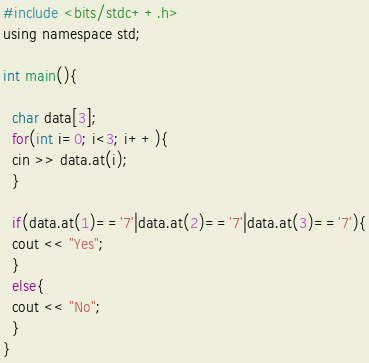Convert code to text. <code><loc_0><loc_0><loc_500><loc_500><_C_>#include <bits/stdc++.h>
using namespace std;

int main(){

  char data[3];
  for(int i=0; i<3; i++){
  cin >> data.at(i);
  }
  
  if(data.at(1)=='7'|data.at(2)=='7'|data.at(3)=='7'){
  cout << "Yes";
  }
  else{
  cout << "No";
  }
}</code> 